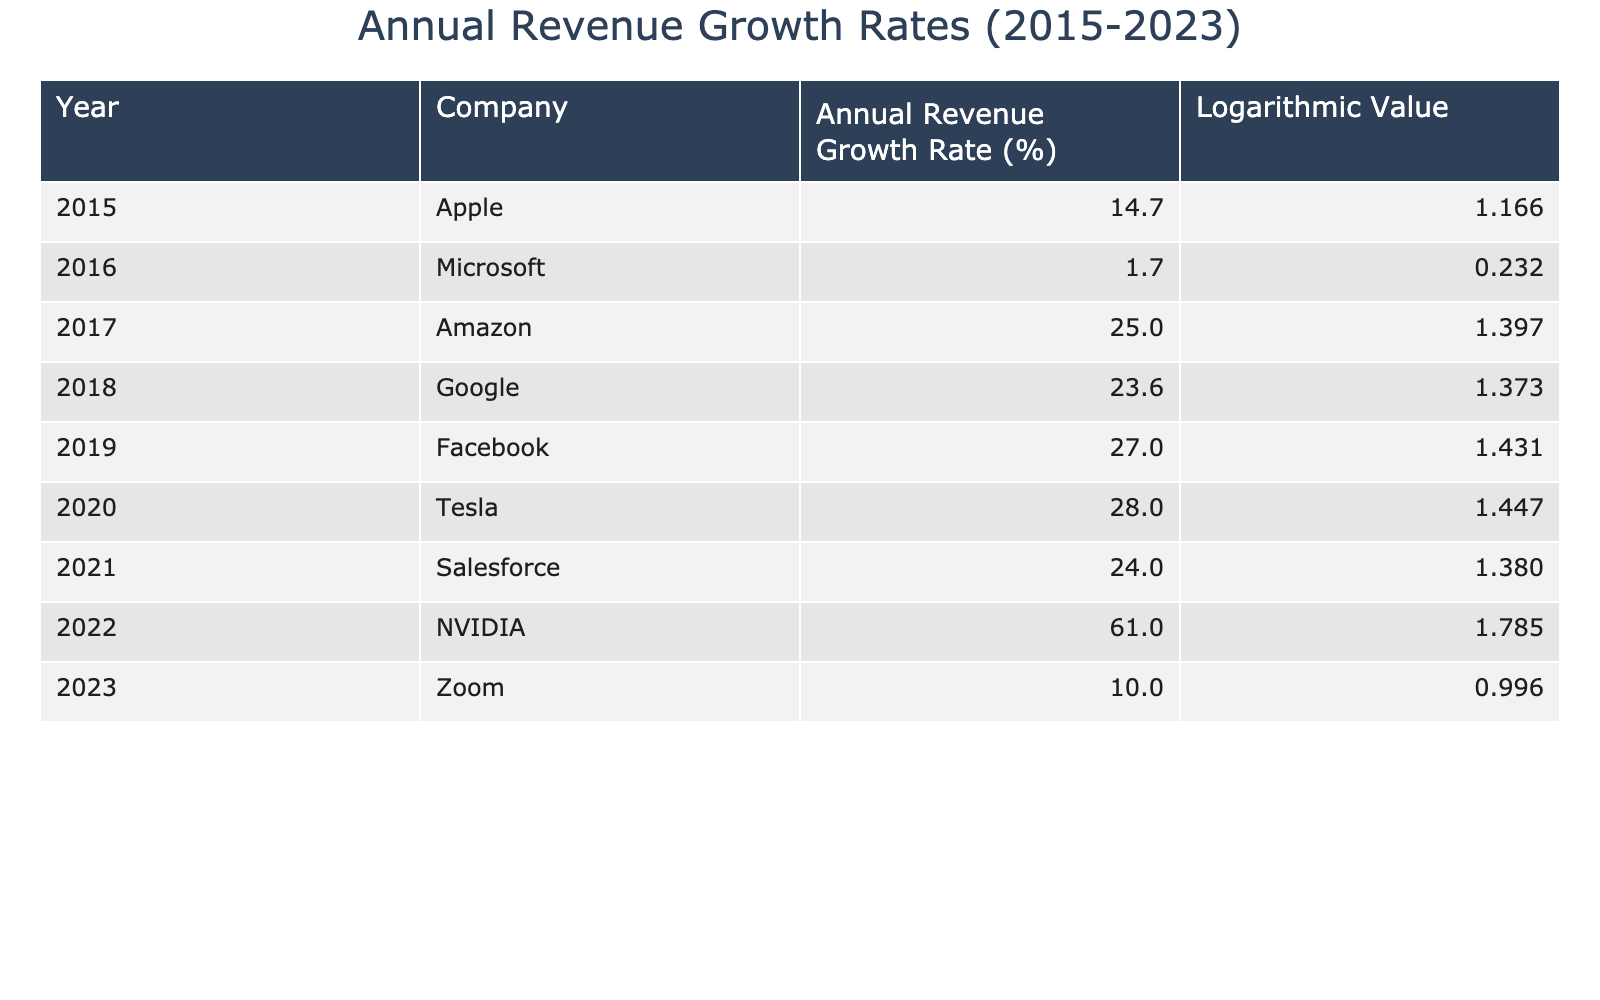What was the annual revenue growth rate for Apple in 2015? The value for Apple in 2015 is found in the row corresponding to the year 2015 under the "Annual Revenue Growth Rate (%)" column. It shows that Apple's growth rate was 14.7%.
Answer: 14.7 Which company had the highest annual revenue growth rate in 2022? In the table, we locate the row for 2022 and examine the "Annual Revenue Growth Rate (%)" column, which shows NVIDIA with a growth rate of 61.0%.
Answer: NVIDIA What is the average growth rate for all companies listed from 2015 to 2023? We sum the growth rates for all companies: (14.7 + 1.7 + 25.0 + 23.6 + 27.0 + 28.0 + 24.0 + 61.0 + 10.0) =  215.0. Then, we divide by the number of companies, which is 9: 215.0 / 9 = 23.89.
Answer: 23.9 Did Zoom have a higher revenue growth rate in 2023 than Apple in 2015? We check the values for both countries: Zoom’s growth rate in 2023 is 10.0%, and Apple’s in 2015 is 14.7%. Since 10.0% is less than 14.7%, the statement is false.
Answer: No Which two companies had growth rates greater than 25% between 2017 and 2021? We need to check each year from 2017 to 2021 and find companies with growth rates over 25%. By examining the data, we see that Amazon (25.0 in 2017) and Tesla (28.0 in 2020) both meet this criterion.
Answer: Amazon and Tesla 